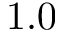Convert formula to latex. <formula><loc_0><loc_0><loc_500><loc_500>1 . 0</formula> 